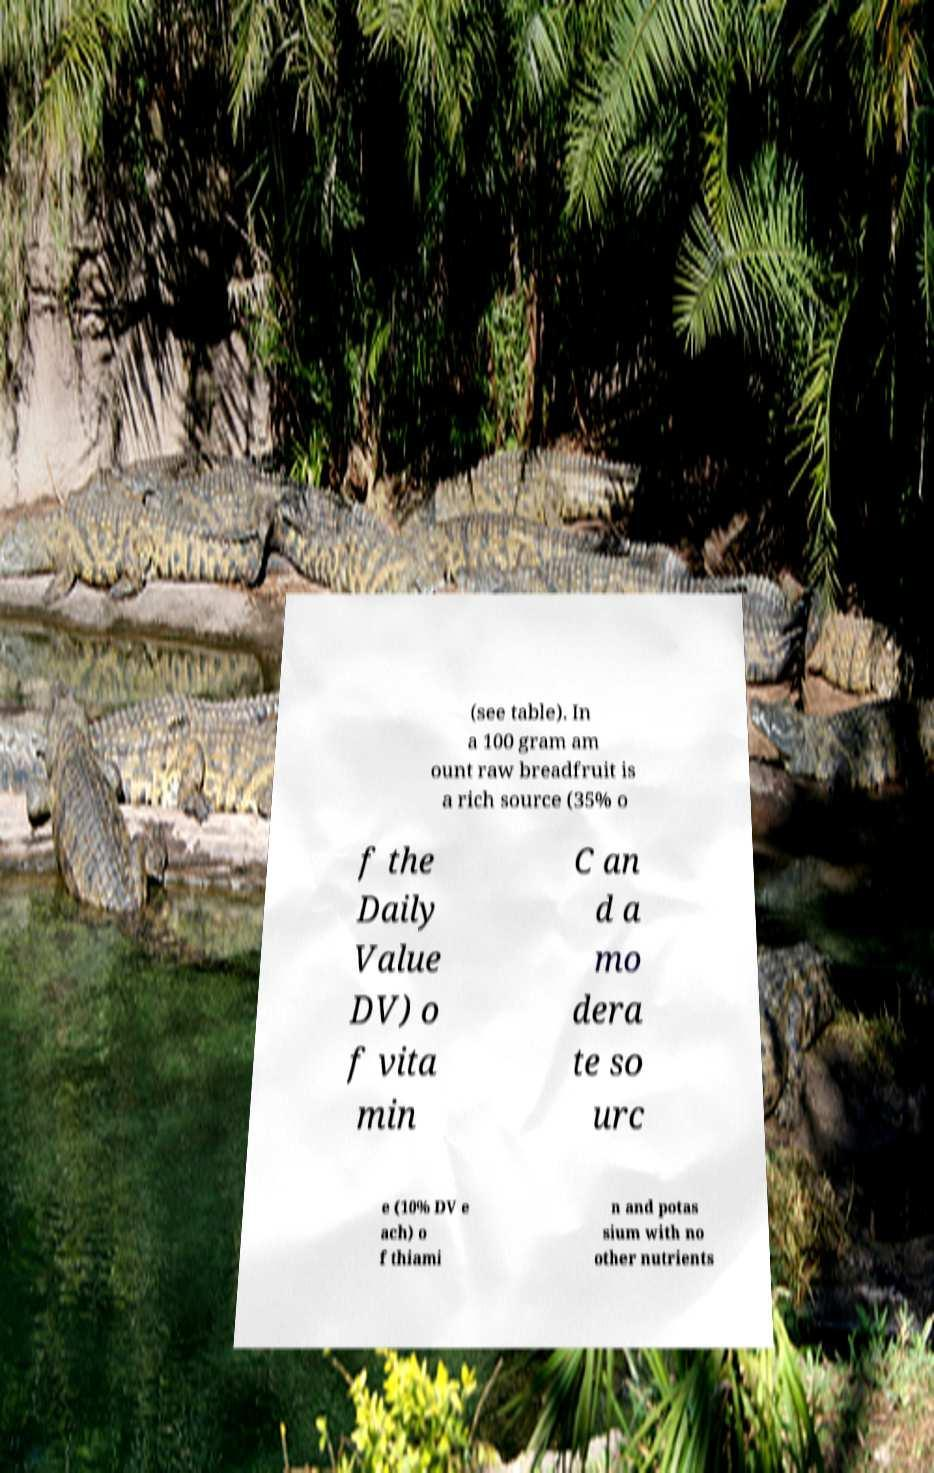Could you assist in decoding the text presented in this image and type it out clearly? (see table). In a 100 gram am ount raw breadfruit is a rich source (35% o f the Daily Value DV) o f vita min C an d a mo dera te so urc e (10% DV e ach) o f thiami n and potas sium with no other nutrients 